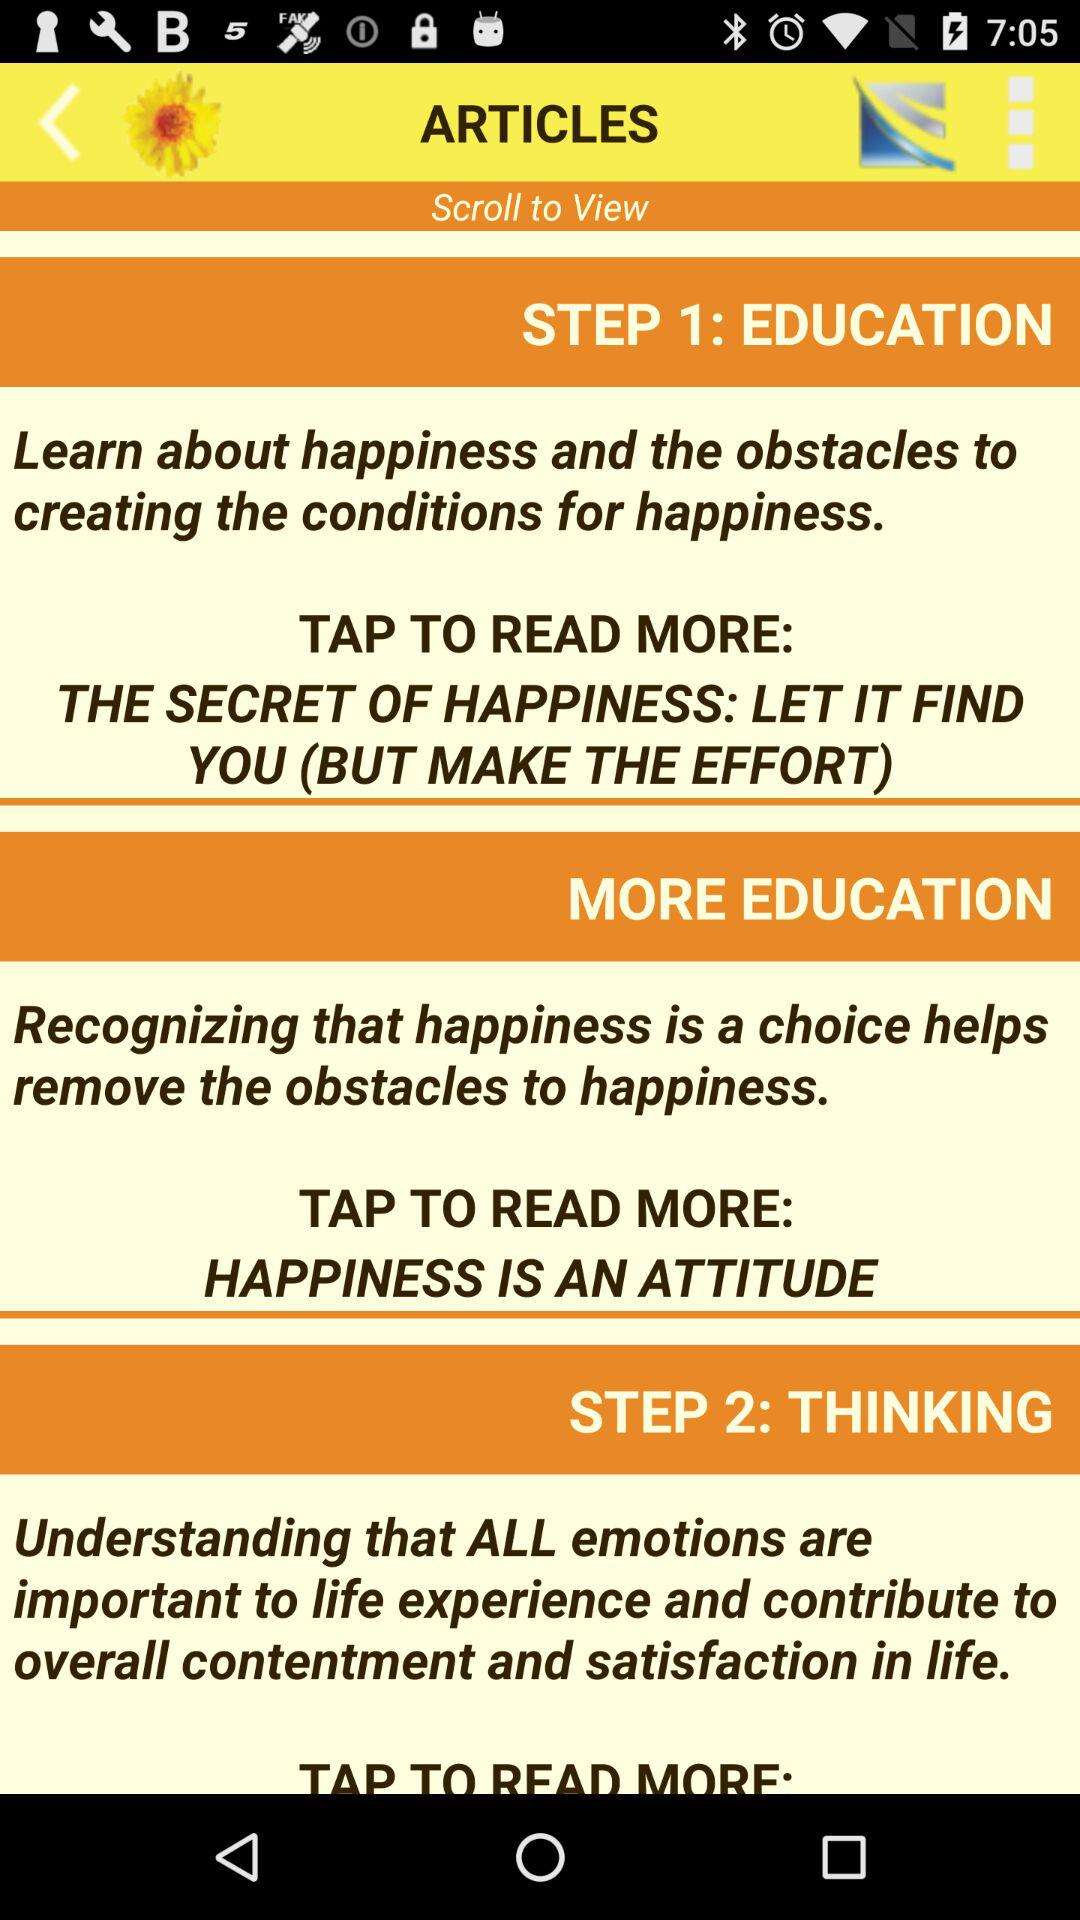How many steps are there in the happiness process?
Answer the question using a single word or phrase. 2 